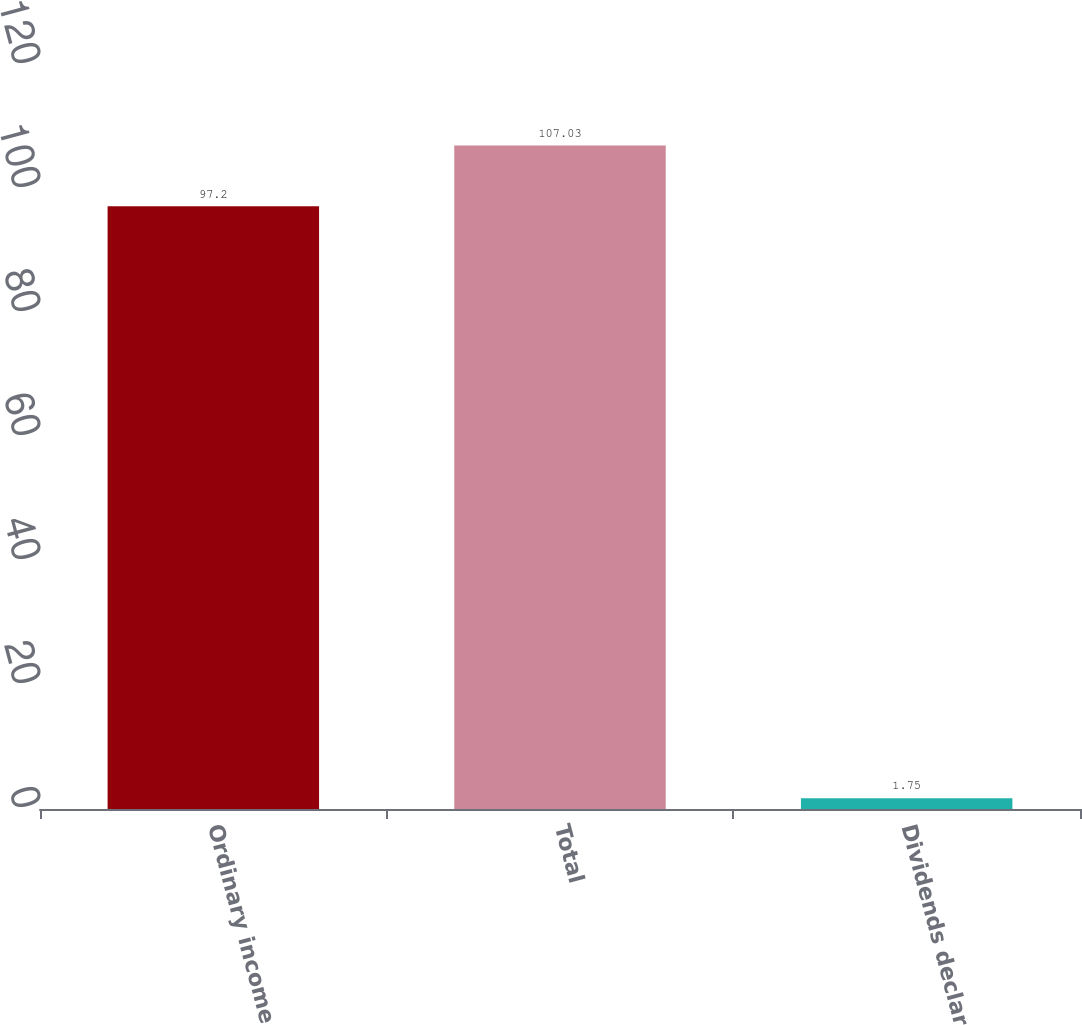<chart> <loc_0><loc_0><loc_500><loc_500><bar_chart><fcel>Ordinary income<fcel>Total<fcel>Dividends declared<nl><fcel>97.2<fcel>107.03<fcel>1.75<nl></chart> 